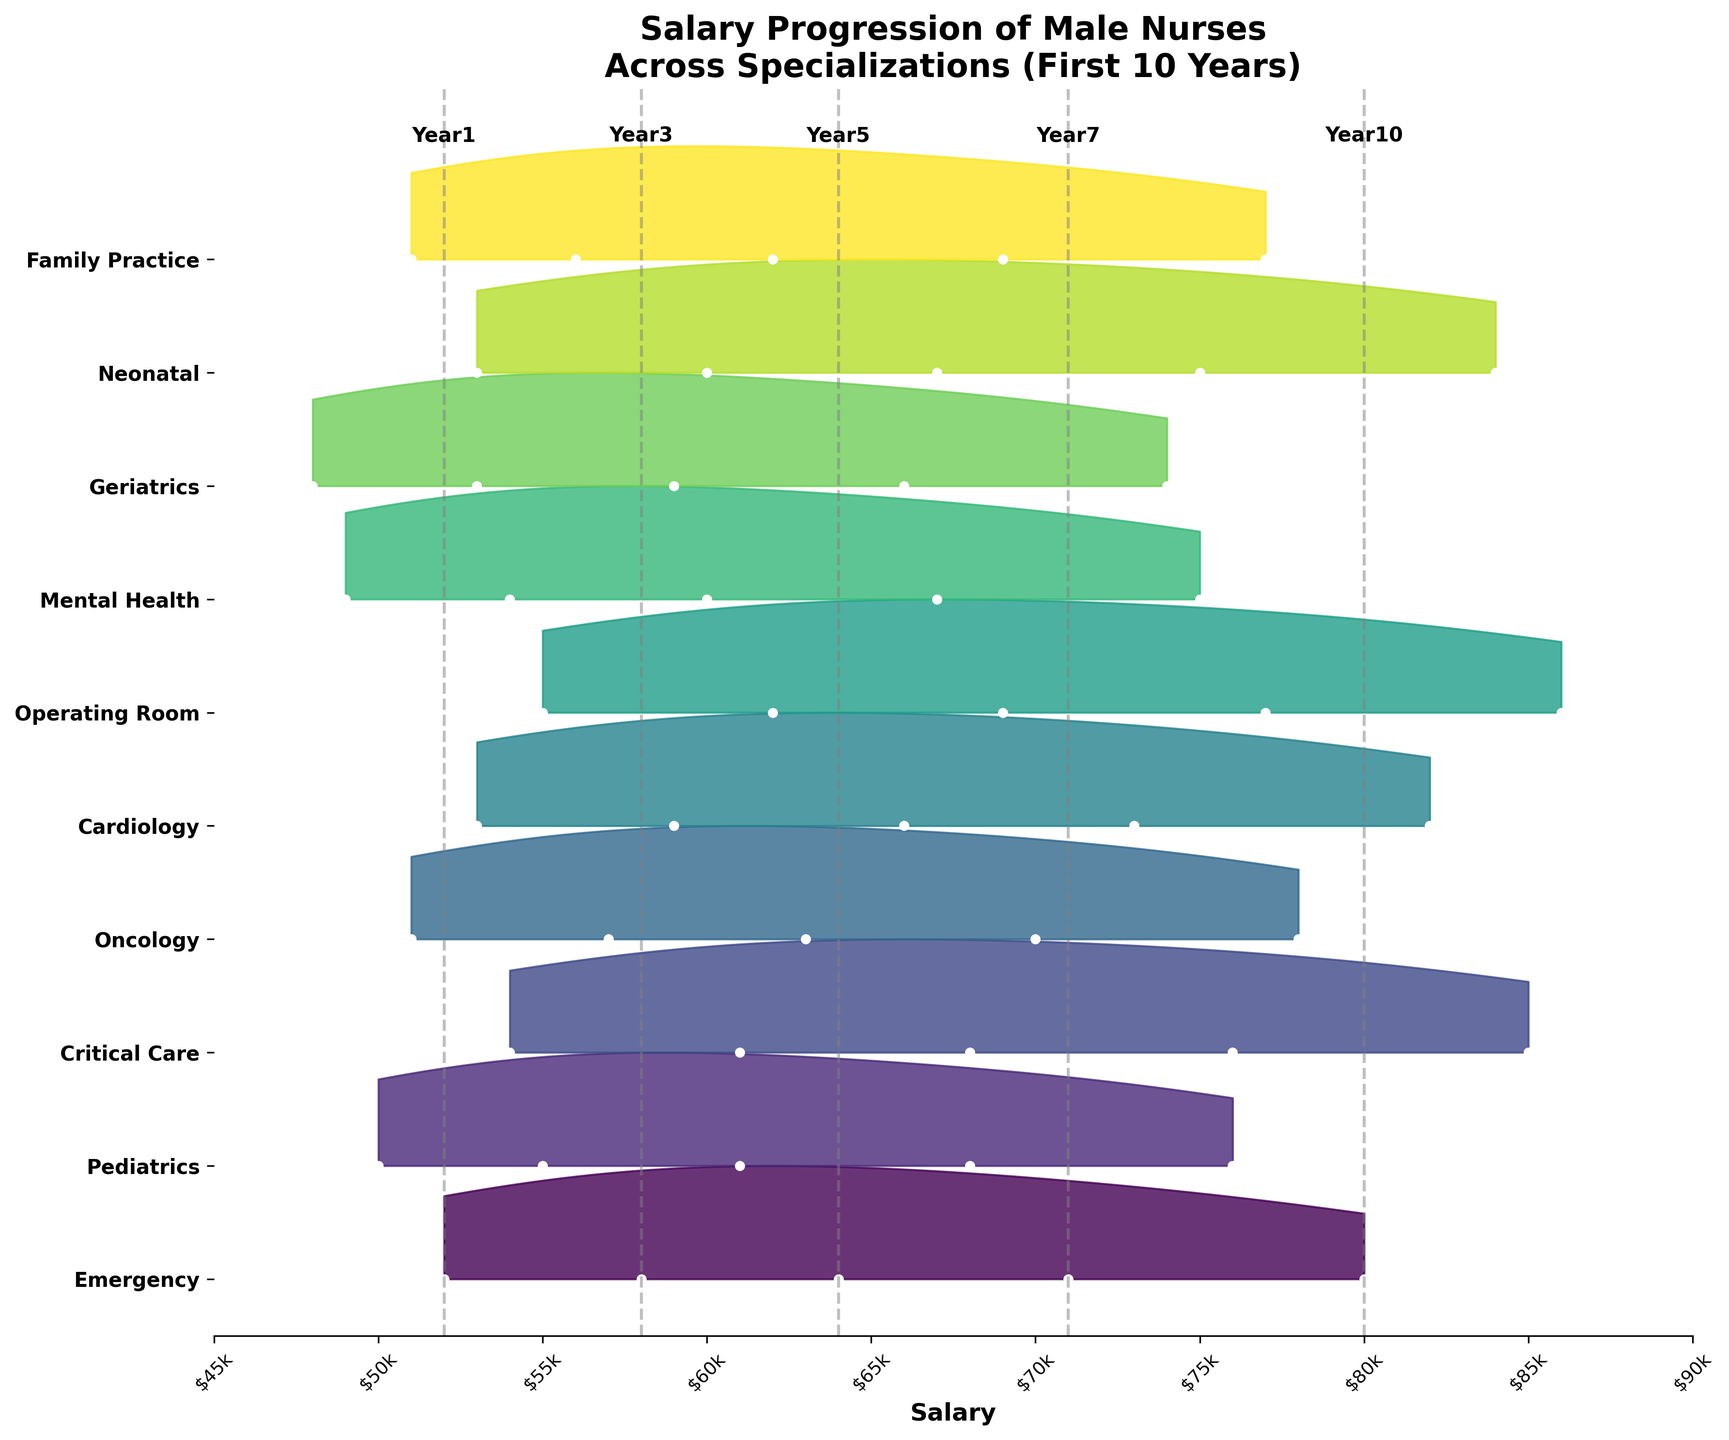Which specialization displays the highest salary progression in the first 10 years? The plot shows different salary progressions for various specializations. The one with the highest salary in the final year (Year 10) indicates the highest salary progression. By visually inspecting the highest values, the Operating Room specialization has the highest Year 10 salary at $86,000.
Answer: Operating Room What is the difference in Year 10 salaries between Mental Health and Cardiology specializations? Identify the Year 10 salaries for Mental Health and Cardiology from the plot. Mental Health has $75,000 and Cardiology has $82,000. Calculate the difference: $82,000 - $75,000 = $7,000.
Answer: $7,000 Which specialization has the lowest starting salary? The first year (Year 1) salary is the starting point. By looking at the leftmost values for each specialization, Geriatrics has the lowest at $48,000.
Answer: Geriatrics What is the average salary in Year 5 across all specializations? Locate the Year 5 salary values across all specializations: $64,000 (Emergency), $61,000 (Pediatrics), $68,000 (Critical Care), $63,000 (Oncology), $66,000 (Cardiology), $69,000 (Operating Room), $60,000 (Mental Health), $59,000 (Geriatrics), $67,000 (Neonatal), and $62,000 (Family Practice). Calculate the average: (64,000+61,000+68,000+63,000+66,000+69,000+60,000+59,000+67,000+62,000)/10 = $63,900.
Answer: $63,900 How does the salary distribution for Pediatrics change over time? Look at the density curves for Pediatrics at different years. Initially clustered around $50,000, it shifts upwards with each year, reaching around $76,000 by Year 10. This indicates steady salary growth.
Answer: Steady growth Which specialization has the most consistent (least varied) salary progression? Identify the specializations with closely clustered salary points on the plot. Oncology shows less spread in its points, indicating more consistent salaries over the years, ranging from $51,000 to $78,000.
Answer: Oncology Between Critical Care and Neonatal, which specialization has a higher median salary in Year 7? Identify Year 7 salary values on the plot for both specializations. Critical Care has $76,000 and Neonatal has $75,000. Thus, Critical Care has a higher median salary in Year 7.
Answer: Critical Care What is the cumulative salary increase for Emergency specialization over the first 10 years? Add the salary increases: $58,000 - $52,000 for Year 1 to Year 3, $64,000 - $58,000 for Year 3 to Year 5, $71,000 - $64,000 for Year 5 to Year 7, and $80,000 - $71,000 for Year 7 to Year 10. Total increase: (6,000 + 6,000 + 7,000 + 9,000) = $28,000.
Answer: $28,000 